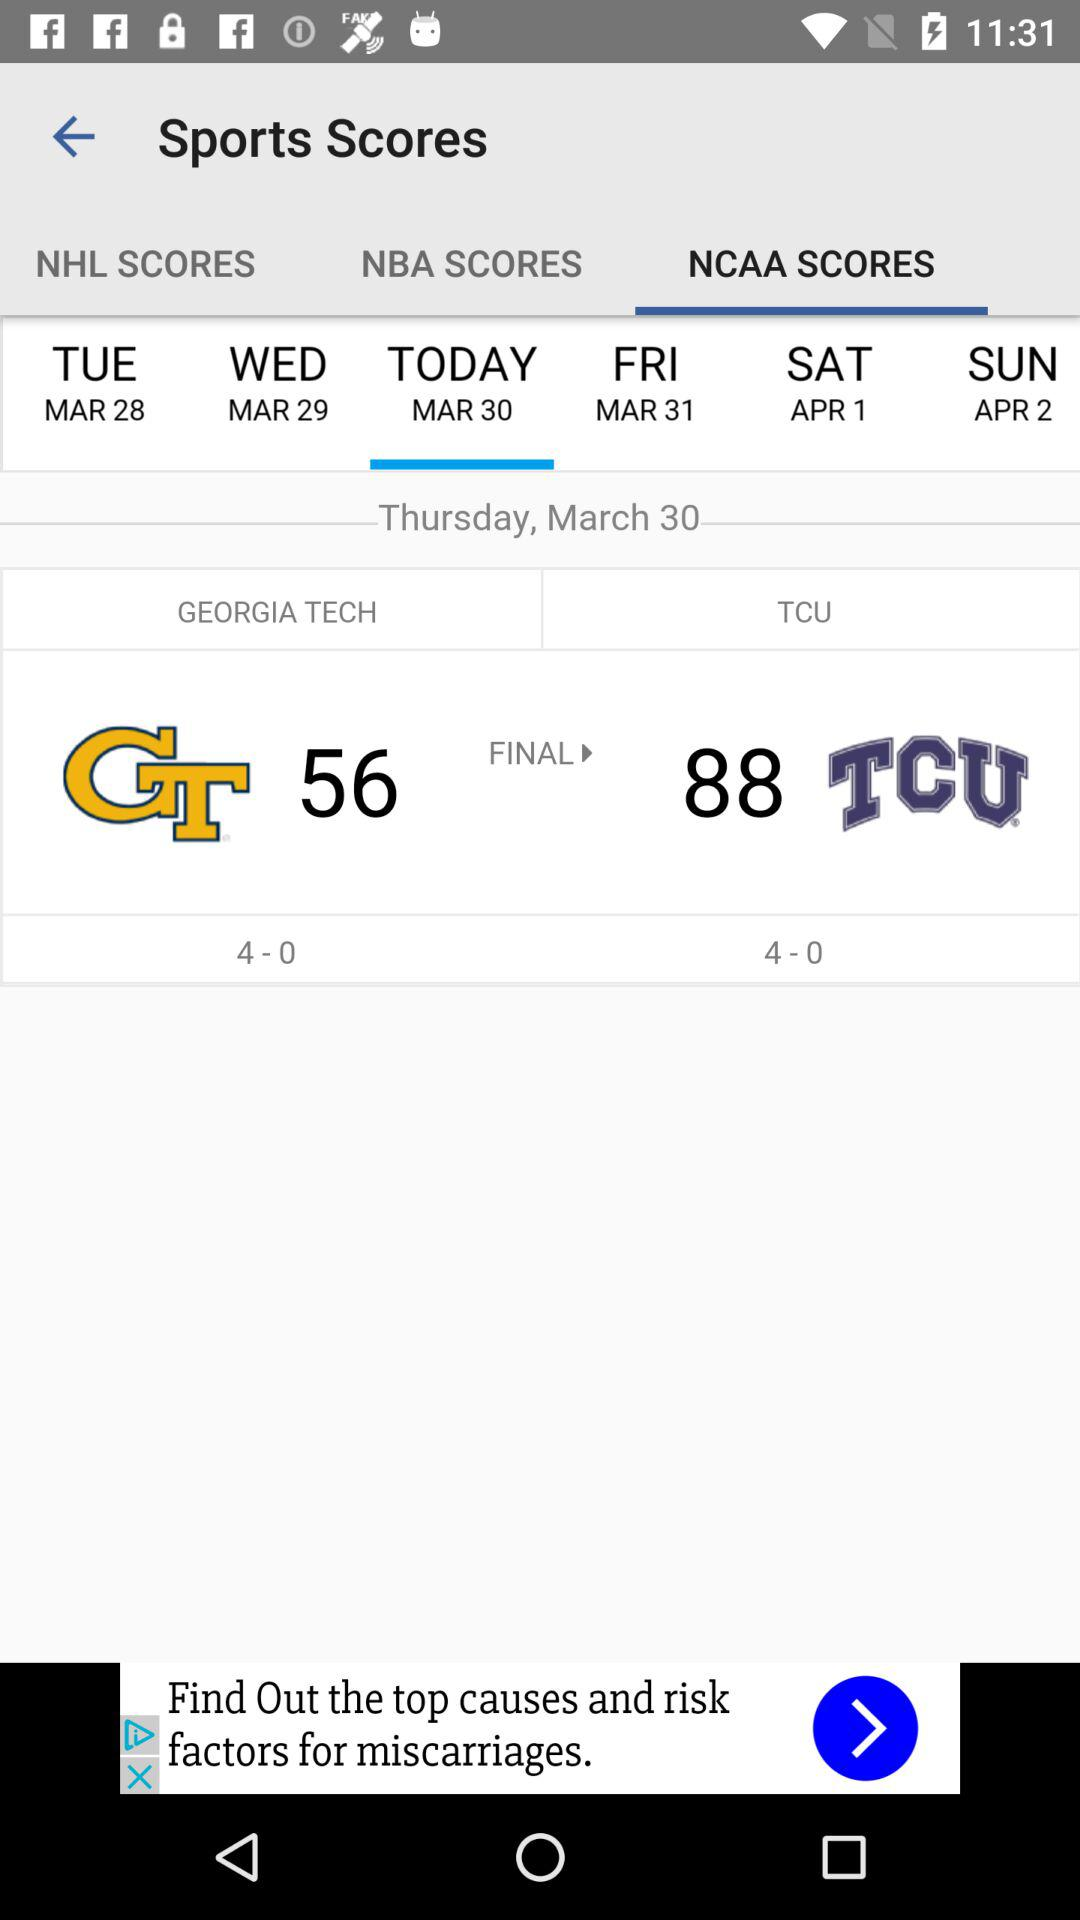What is Georgia Tech's score? Georgia Tech's score is 56. 